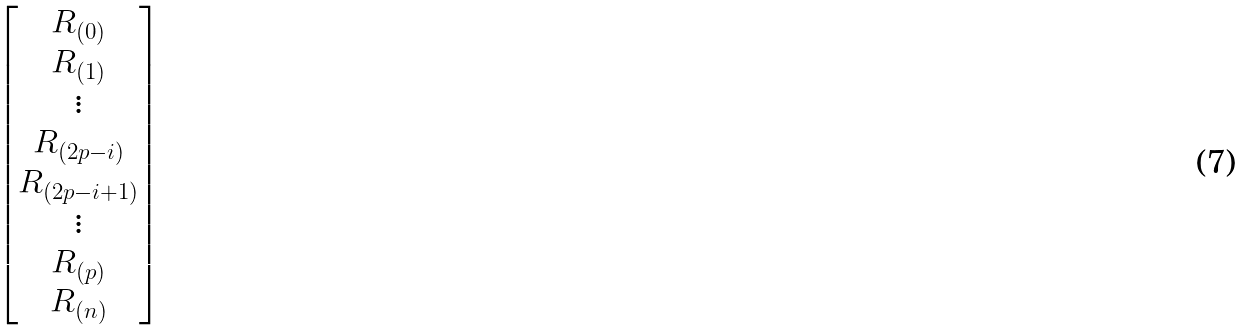<formula> <loc_0><loc_0><loc_500><loc_500>\begin{bmatrix} R _ { ( 0 ) } \\ R _ { ( 1 ) } \\ \vdots \\ R _ { ( 2 p - i ) } \\ R _ { ( 2 p - i + 1 ) } \\ \vdots \\ R _ { ( p ) } \\ R _ { ( n ) } \\ \end{bmatrix}</formula> 